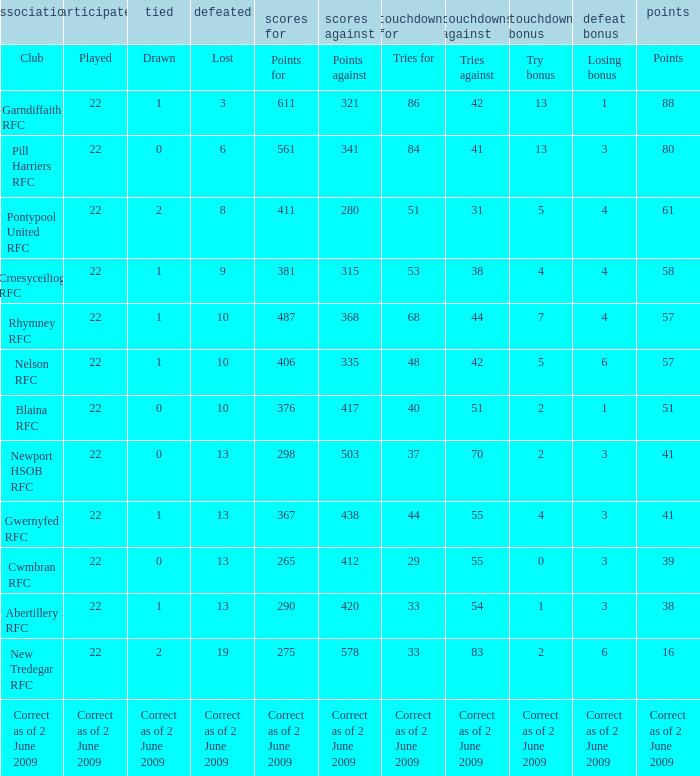How many tries against did the club with 1 drawn and 41 points have? 55.0. 